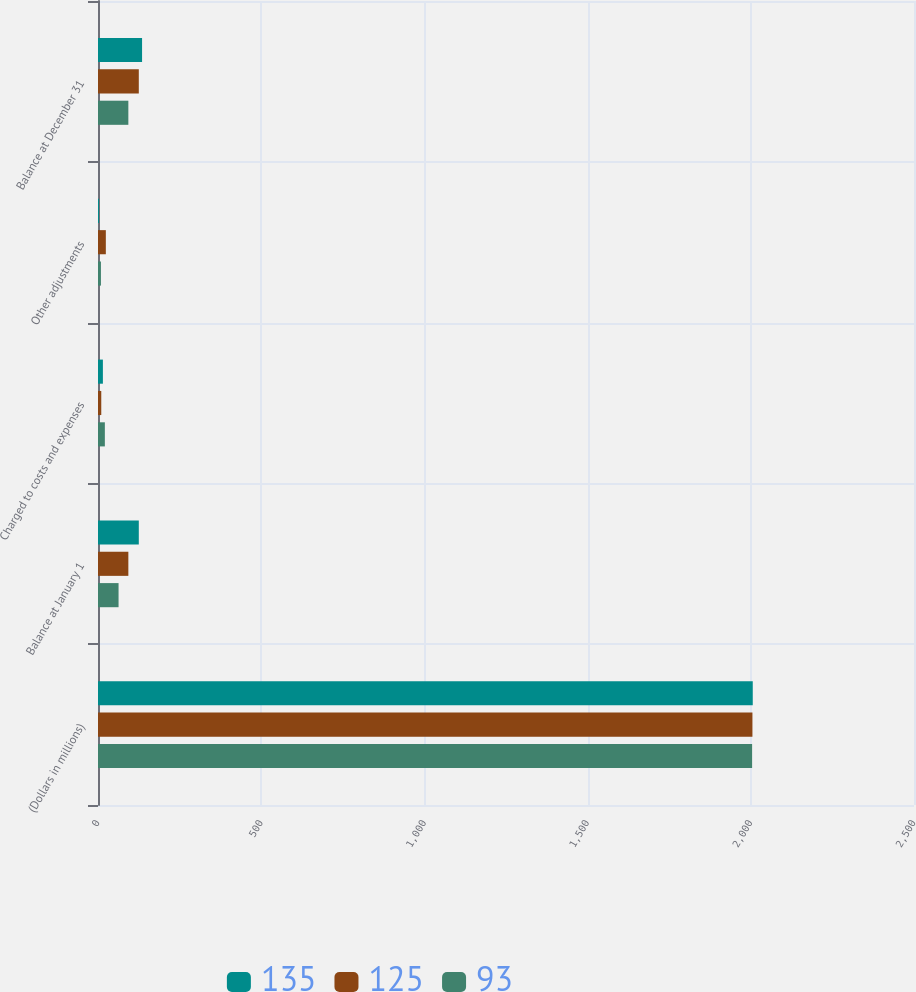Convert chart. <chart><loc_0><loc_0><loc_500><loc_500><stacked_bar_chart><ecel><fcel>(Dollars in millions)<fcel>Balance at January 1<fcel>Charged to costs and expenses<fcel>Other adjustments<fcel>Balance at December 31<nl><fcel>135<fcel>2006<fcel>125<fcel>15<fcel>3<fcel>135<nl><fcel>125<fcel>2005<fcel>93<fcel>10<fcel>24<fcel>125<nl><fcel>93<fcel>2004<fcel>63<fcel>21<fcel>9<fcel>93<nl></chart> 